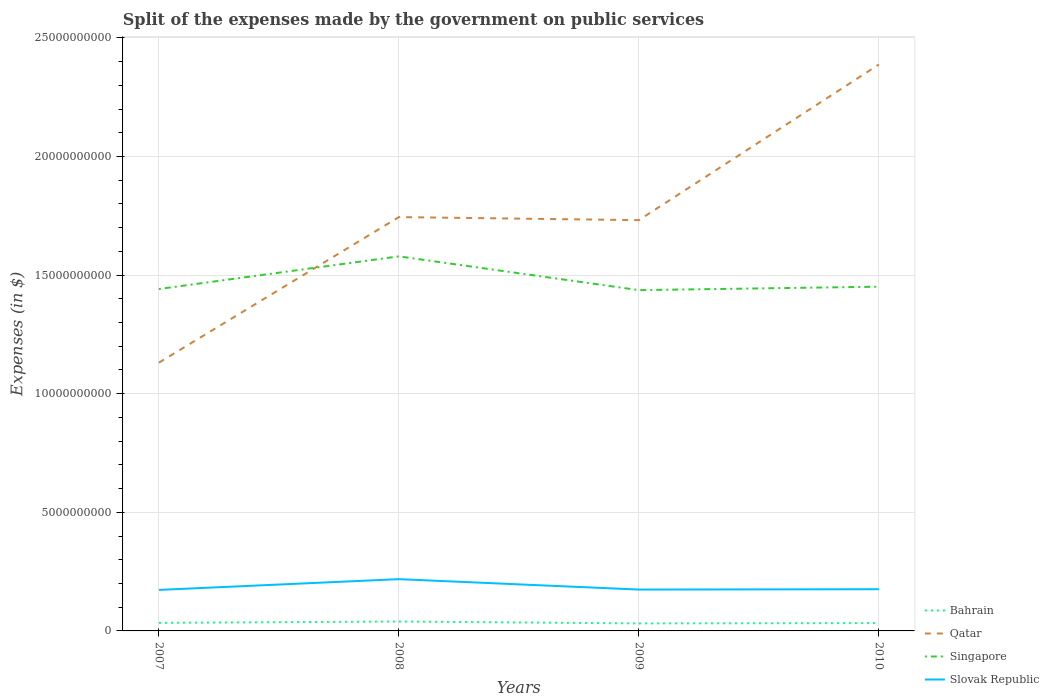How many different coloured lines are there?
Give a very brief answer. 4. Does the line corresponding to Qatar intersect with the line corresponding to Bahrain?
Offer a terse response. No. Across all years, what is the maximum expenses made by the government on public services in Qatar?
Offer a very short reply. 1.13e+1. In which year was the expenses made by the government on public services in Qatar maximum?
Make the answer very short. 2007. What is the total expenses made by the government on public services in Qatar in the graph?
Give a very brief answer. -6.14e+09. What is the difference between the highest and the second highest expenses made by the government on public services in Qatar?
Make the answer very short. 1.26e+1. What is the difference between the highest and the lowest expenses made by the government on public services in Qatar?
Your answer should be very brief. 1. How many lines are there?
Keep it short and to the point. 4. How many years are there in the graph?
Provide a succinct answer. 4. What is the difference between two consecutive major ticks on the Y-axis?
Your answer should be compact. 5.00e+09. Are the values on the major ticks of Y-axis written in scientific E-notation?
Offer a very short reply. No. Does the graph contain any zero values?
Offer a terse response. No. Does the graph contain grids?
Offer a terse response. Yes. How are the legend labels stacked?
Keep it short and to the point. Vertical. What is the title of the graph?
Ensure brevity in your answer.  Split of the expenses made by the government on public services. What is the label or title of the Y-axis?
Your response must be concise. Expenses (in $). What is the Expenses (in $) in Bahrain in 2007?
Ensure brevity in your answer.  3.39e+08. What is the Expenses (in $) in Qatar in 2007?
Offer a very short reply. 1.13e+1. What is the Expenses (in $) in Singapore in 2007?
Provide a short and direct response. 1.44e+1. What is the Expenses (in $) in Slovak Republic in 2007?
Provide a short and direct response. 1.73e+09. What is the Expenses (in $) of Bahrain in 2008?
Your response must be concise. 3.96e+08. What is the Expenses (in $) in Qatar in 2008?
Your response must be concise. 1.74e+1. What is the Expenses (in $) of Singapore in 2008?
Give a very brief answer. 1.58e+1. What is the Expenses (in $) of Slovak Republic in 2008?
Keep it short and to the point. 2.18e+09. What is the Expenses (in $) in Bahrain in 2009?
Your response must be concise. 3.18e+08. What is the Expenses (in $) of Qatar in 2009?
Provide a short and direct response. 1.73e+1. What is the Expenses (in $) of Singapore in 2009?
Offer a terse response. 1.44e+1. What is the Expenses (in $) of Slovak Republic in 2009?
Ensure brevity in your answer.  1.74e+09. What is the Expenses (in $) in Bahrain in 2010?
Your answer should be compact. 3.30e+08. What is the Expenses (in $) of Qatar in 2010?
Keep it short and to the point. 2.39e+1. What is the Expenses (in $) of Singapore in 2010?
Give a very brief answer. 1.45e+1. What is the Expenses (in $) of Slovak Republic in 2010?
Offer a terse response. 1.76e+09. Across all years, what is the maximum Expenses (in $) of Bahrain?
Make the answer very short. 3.96e+08. Across all years, what is the maximum Expenses (in $) of Qatar?
Make the answer very short. 2.39e+1. Across all years, what is the maximum Expenses (in $) of Singapore?
Provide a succinct answer. 1.58e+1. Across all years, what is the maximum Expenses (in $) in Slovak Republic?
Ensure brevity in your answer.  2.18e+09. Across all years, what is the minimum Expenses (in $) in Bahrain?
Your answer should be compact. 3.18e+08. Across all years, what is the minimum Expenses (in $) in Qatar?
Keep it short and to the point. 1.13e+1. Across all years, what is the minimum Expenses (in $) of Singapore?
Your answer should be very brief. 1.44e+1. Across all years, what is the minimum Expenses (in $) in Slovak Republic?
Give a very brief answer. 1.73e+09. What is the total Expenses (in $) in Bahrain in the graph?
Your response must be concise. 1.38e+09. What is the total Expenses (in $) of Qatar in the graph?
Offer a very short reply. 7.00e+1. What is the total Expenses (in $) in Singapore in the graph?
Give a very brief answer. 5.91e+1. What is the total Expenses (in $) of Slovak Republic in the graph?
Provide a short and direct response. 7.41e+09. What is the difference between the Expenses (in $) of Bahrain in 2007 and that in 2008?
Give a very brief answer. -5.70e+07. What is the difference between the Expenses (in $) in Qatar in 2007 and that in 2008?
Offer a terse response. -6.14e+09. What is the difference between the Expenses (in $) in Singapore in 2007 and that in 2008?
Your answer should be very brief. -1.38e+09. What is the difference between the Expenses (in $) of Slovak Republic in 2007 and that in 2008?
Make the answer very short. -4.53e+08. What is the difference between the Expenses (in $) in Bahrain in 2007 and that in 2009?
Provide a short and direct response. 2.19e+07. What is the difference between the Expenses (in $) of Qatar in 2007 and that in 2009?
Offer a terse response. -6.01e+09. What is the difference between the Expenses (in $) of Singapore in 2007 and that in 2009?
Ensure brevity in your answer.  4.70e+07. What is the difference between the Expenses (in $) in Slovak Republic in 2007 and that in 2009?
Offer a terse response. -1.42e+07. What is the difference between the Expenses (in $) in Bahrain in 2007 and that in 2010?
Give a very brief answer. 9.20e+06. What is the difference between the Expenses (in $) in Qatar in 2007 and that in 2010?
Give a very brief answer. -1.26e+1. What is the difference between the Expenses (in $) in Singapore in 2007 and that in 2010?
Offer a terse response. -9.78e+07. What is the difference between the Expenses (in $) in Slovak Republic in 2007 and that in 2010?
Your answer should be very brief. -2.88e+07. What is the difference between the Expenses (in $) of Bahrain in 2008 and that in 2009?
Offer a very short reply. 7.90e+07. What is the difference between the Expenses (in $) of Qatar in 2008 and that in 2009?
Make the answer very short. 1.29e+08. What is the difference between the Expenses (in $) of Singapore in 2008 and that in 2009?
Give a very brief answer. 1.42e+09. What is the difference between the Expenses (in $) of Slovak Republic in 2008 and that in 2009?
Provide a short and direct response. 4.39e+08. What is the difference between the Expenses (in $) of Bahrain in 2008 and that in 2010?
Your answer should be very brief. 6.62e+07. What is the difference between the Expenses (in $) in Qatar in 2008 and that in 2010?
Provide a short and direct response. -6.43e+09. What is the difference between the Expenses (in $) of Singapore in 2008 and that in 2010?
Ensure brevity in your answer.  1.28e+09. What is the difference between the Expenses (in $) in Slovak Republic in 2008 and that in 2010?
Provide a short and direct response. 4.24e+08. What is the difference between the Expenses (in $) of Bahrain in 2009 and that in 2010?
Offer a very short reply. -1.27e+07. What is the difference between the Expenses (in $) of Qatar in 2009 and that in 2010?
Your answer should be compact. -6.56e+09. What is the difference between the Expenses (in $) in Singapore in 2009 and that in 2010?
Provide a short and direct response. -1.45e+08. What is the difference between the Expenses (in $) in Slovak Republic in 2009 and that in 2010?
Your response must be concise. -1.45e+07. What is the difference between the Expenses (in $) of Bahrain in 2007 and the Expenses (in $) of Qatar in 2008?
Make the answer very short. -1.71e+1. What is the difference between the Expenses (in $) of Bahrain in 2007 and the Expenses (in $) of Singapore in 2008?
Give a very brief answer. -1.55e+1. What is the difference between the Expenses (in $) in Bahrain in 2007 and the Expenses (in $) in Slovak Republic in 2008?
Offer a terse response. -1.84e+09. What is the difference between the Expenses (in $) of Qatar in 2007 and the Expenses (in $) of Singapore in 2008?
Make the answer very short. -4.48e+09. What is the difference between the Expenses (in $) in Qatar in 2007 and the Expenses (in $) in Slovak Republic in 2008?
Offer a terse response. 9.13e+09. What is the difference between the Expenses (in $) in Singapore in 2007 and the Expenses (in $) in Slovak Republic in 2008?
Provide a short and direct response. 1.22e+1. What is the difference between the Expenses (in $) of Bahrain in 2007 and the Expenses (in $) of Qatar in 2009?
Provide a succinct answer. -1.70e+1. What is the difference between the Expenses (in $) in Bahrain in 2007 and the Expenses (in $) in Singapore in 2009?
Your response must be concise. -1.40e+1. What is the difference between the Expenses (in $) in Bahrain in 2007 and the Expenses (in $) in Slovak Republic in 2009?
Provide a short and direct response. -1.40e+09. What is the difference between the Expenses (in $) in Qatar in 2007 and the Expenses (in $) in Singapore in 2009?
Your answer should be compact. -3.06e+09. What is the difference between the Expenses (in $) of Qatar in 2007 and the Expenses (in $) of Slovak Republic in 2009?
Keep it short and to the point. 9.57e+09. What is the difference between the Expenses (in $) of Singapore in 2007 and the Expenses (in $) of Slovak Republic in 2009?
Offer a terse response. 1.27e+1. What is the difference between the Expenses (in $) of Bahrain in 2007 and the Expenses (in $) of Qatar in 2010?
Keep it short and to the point. -2.35e+1. What is the difference between the Expenses (in $) in Bahrain in 2007 and the Expenses (in $) in Singapore in 2010?
Ensure brevity in your answer.  -1.42e+1. What is the difference between the Expenses (in $) of Bahrain in 2007 and the Expenses (in $) of Slovak Republic in 2010?
Provide a succinct answer. -1.42e+09. What is the difference between the Expenses (in $) in Qatar in 2007 and the Expenses (in $) in Singapore in 2010?
Provide a succinct answer. -3.20e+09. What is the difference between the Expenses (in $) in Qatar in 2007 and the Expenses (in $) in Slovak Republic in 2010?
Ensure brevity in your answer.  9.55e+09. What is the difference between the Expenses (in $) in Singapore in 2007 and the Expenses (in $) in Slovak Republic in 2010?
Ensure brevity in your answer.  1.27e+1. What is the difference between the Expenses (in $) of Bahrain in 2008 and the Expenses (in $) of Qatar in 2009?
Make the answer very short. -1.69e+1. What is the difference between the Expenses (in $) in Bahrain in 2008 and the Expenses (in $) in Singapore in 2009?
Ensure brevity in your answer.  -1.40e+1. What is the difference between the Expenses (in $) of Bahrain in 2008 and the Expenses (in $) of Slovak Republic in 2009?
Provide a succinct answer. -1.35e+09. What is the difference between the Expenses (in $) in Qatar in 2008 and the Expenses (in $) in Singapore in 2009?
Your answer should be compact. 3.08e+09. What is the difference between the Expenses (in $) of Qatar in 2008 and the Expenses (in $) of Slovak Republic in 2009?
Provide a short and direct response. 1.57e+1. What is the difference between the Expenses (in $) in Singapore in 2008 and the Expenses (in $) in Slovak Republic in 2009?
Your response must be concise. 1.40e+1. What is the difference between the Expenses (in $) in Bahrain in 2008 and the Expenses (in $) in Qatar in 2010?
Provide a short and direct response. -2.35e+1. What is the difference between the Expenses (in $) in Bahrain in 2008 and the Expenses (in $) in Singapore in 2010?
Provide a short and direct response. -1.41e+1. What is the difference between the Expenses (in $) in Bahrain in 2008 and the Expenses (in $) in Slovak Republic in 2010?
Offer a very short reply. -1.36e+09. What is the difference between the Expenses (in $) in Qatar in 2008 and the Expenses (in $) in Singapore in 2010?
Provide a short and direct response. 2.93e+09. What is the difference between the Expenses (in $) of Qatar in 2008 and the Expenses (in $) of Slovak Republic in 2010?
Make the answer very short. 1.57e+1. What is the difference between the Expenses (in $) in Singapore in 2008 and the Expenses (in $) in Slovak Republic in 2010?
Offer a very short reply. 1.40e+1. What is the difference between the Expenses (in $) of Bahrain in 2009 and the Expenses (in $) of Qatar in 2010?
Give a very brief answer. -2.36e+1. What is the difference between the Expenses (in $) of Bahrain in 2009 and the Expenses (in $) of Singapore in 2010?
Your answer should be compact. -1.42e+1. What is the difference between the Expenses (in $) of Bahrain in 2009 and the Expenses (in $) of Slovak Republic in 2010?
Provide a short and direct response. -1.44e+09. What is the difference between the Expenses (in $) of Qatar in 2009 and the Expenses (in $) of Singapore in 2010?
Your answer should be very brief. 2.81e+09. What is the difference between the Expenses (in $) of Qatar in 2009 and the Expenses (in $) of Slovak Republic in 2010?
Make the answer very short. 1.56e+1. What is the difference between the Expenses (in $) in Singapore in 2009 and the Expenses (in $) in Slovak Republic in 2010?
Offer a terse response. 1.26e+1. What is the average Expenses (in $) in Bahrain per year?
Ensure brevity in your answer.  3.46e+08. What is the average Expenses (in $) of Qatar per year?
Keep it short and to the point. 1.75e+1. What is the average Expenses (in $) in Singapore per year?
Give a very brief answer. 1.48e+1. What is the average Expenses (in $) of Slovak Republic per year?
Make the answer very short. 1.85e+09. In the year 2007, what is the difference between the Expenses (in $) in Bahrain and Expenses (in $) in Qatar?
Provide a short and direct response. -1.10e+1. In the year 2007, what is the difference between the Expenses (in $) in Bahrain and Expenses (in $) in Singapore?
Provide a short and direct response. -1.41e+1. In the year 2007, what is the difference between the Expenses (in $) in Bahrain and Expenses (in $) in Slovak Republic?
Provide a succinct answer. -1.39e+09. In the year 2007, what is the difference between the Expenses (in $) of Qatar and Expenses (in $) of Singapore?
Your response must be concise. -3.10e+09. In the year 2007, what is the difference between the Expenses (in $) in Qatar and Expenses (in $) in Slovak Republic?
Provide a short and direct response. 9.58e+09. In the year 2007, what is the difference between the Expenses (in $) of Singapore and Expenses (in $) of Slovak Republic?
Keep it short and to the point. 1.27e+1. In the year 2008, what is the difference between the Expenses (in $) of Bahrain and Expenses (in $) of Qatar?
Your response must be concise. -1.70e+1. In the year 2008, what is the difference between the Expenses (in $) of Bahrain and Expenses (in $) of Singapore?
Provide a short and direct response. -1.54e+1. In the year 2008, what is the difference between the Expenses (in $) of Bahrain and Expenses (in $) of Slovak Republic?
Offer a very short reply. -1.79e+09. In the year 2008, what is the difference between the Expenses (in $) of Qatar and Expenses (in $) of Singapore?
Ensure brevity in your answer.  1.66e+09. In the year 2008, what is the difference between the Expenses (in $) of Qatar and Expenses (in $) of Slovak Republic?
Your answer should be compact. 1.53e+1. In the year 2008, what is the difference between the Expenses (in $) of Singapore and Expenses (in $) of Slovak Republic?
Your answer should be compact. 1.36e+1. In the year 2009, what is the difference between the Expenses (in $) of Bahrain and Expenses (in $) of Qatar?
Offer a terse response. -1.70e+1. In the year 2009, what is the difference between the Expenses (in $) of Bahrain and Expenses (in $) of Singapore?
Your answer should be compact. -1.40e+1. In the year 2009, what is the difference between the Expenses (in $) of Bahrain and Expenses (in $) of Slovak Republic?
Provide a short and direct response. -1.43e+09. In the year 2009, what is the difference between the Expenses (in $) in Qatar and Expenses (in $) in Singapore?
Ensure brevity in your answer.  2.95e+09. In the year 2009, what is the difference between the Expenses (in $) of Qatar and Expenses (in $) of Slovak Republic?
Provide a succinct answer. 1.56e+1. In the year 2009, what is the difference between the Expenses (in $) of Singapore and Expenses (in $) of Slovak Republic?
Offer a terse response. 1.26e+1. In the year 2010, what is the difference between the Expenses (in $) in Bahrain and Expenses (in $) in Qatar?
Make the answer very short. -2.35e+1. In the year 2010, what is the difference between the Expenses (in $) in Bahrain and Expenses (in $) in Singapore?
Keep it short and to the point. -1.42e+1. In the year 2010, what is the difference between the Expenses (in $) in Bahrain and Expenses (in $) in Slovak Republic?
Your answer should be compact. -1.43e+09. In the year 2010, what is the difference between the Expenses (in $) in Qatar and Expenses (in $) in Singapore?
Make the answer very short. 9.37e+09. In the year 2010, what is the difference between the Expenses (in $) of Qatar and Expenses (in $) of Slovak Republic?
Offer a very short reply. 2.21e+1. In the year 2010, what is the difference between the Expenses (in $) of Singapore and Expenses (in $) of Slovak Republic?
Give a very brief answer. 1.28e+1. What is the ratio of the Expenses (in $) of Bahrain in 2007 to that in 2008?
Your answer should be very brief. 0.86. What is the ratio of the Expenses (in $) of Qatar in 2007 to that in 2008?
Keep it short and to the point. 0.65. What is the ratio of the Expenses (in $) in Singapore in 2007 to that in 2008?
Ensure brevity in your answer.  0.91. What is the ratio of the Expenses (in $) in Slovak Republic in 2007 to that in 2008?
Keep it short and to the point. 0.79. What is the ratio of the Expenses (in $) of Bahrain in 2007 to that in 2009?
Your answer should be very brief. 1.07. What is the ratio of the Expenses (in $) of Qatar in 2007 to that in 2009?
Provide a succinct answer. 0.65. What is the ratio of the Expenses (in $) of Slovak Republic in 2007 to that in 2009?
Your answer should be very brief. 0.99. What is the ratio of the Expenses (in $) of Bahrain in 2007 to that in 2010?
Provide a short and direct response. 1.03. What is the ratio of the Expenses (in $) in Qatar in 2007 to that in 2010?
Provide a short and direct response. 0.47. What is the ratio of the Expenses (in $) in Singapore in 2007 to that in 2010?
Provide a short and direct response. 0.99. What is the ratio of the Expenses (in $) of Slovak Republic in 2007 to that in 2010?
Make the answer very short. 0.98. What is the ratio of the Expenses (in $) of Bahrain in 2008 to that in 2009?
Offer a terse response. 1.25. What is the ratio of the Expenses (in $) in Qatar in 2008 to that in 2009?
Keep it short and to the point. 1.01. What is the ratio of the Expenses (in $) in Singapore in 2008 to that in 2009?
Your answer should be very brief. 1.1. What is the ratio of the Expenses (in $) in Slovak Republic in 2008 to that in 2009?
Your answer should be compact. 1.25. What is the ratio of the Expenses (in $) in Bahrain in 2008 to that in 2010?
Offer a very short reply. 1.2. What is the ratio of the Expenses (in $) of Qatar in 2008 to that in 2010?
Your answer should be very brief. 0.73. What is the ratio of the Expenses (in $) in Singapore in 2008 to that in 2010?
Offer a very short reply. 1.09. What is the ratio of the Expenses (in $) of Slovak Republic in 2008 to that in 2010?
Your answer should be compact. 1.24. What is the ratio of the Expenses (in $) of Bahrain in 2009 to that in 2010?
Your response must be concise. 0.96. What is the ratio of the Expenses (in $) of Qatar in 2009 to that in 2010?
Ensure brevity in your answer.  0.73. What is the difference between the highest and the second highest Expenses (in $) in Bahrain?
Your answer should be very brief. 5.70e+07. What is the difference between the highest and the second highest Expenses (in $) in Qatar?
Offer a very short reply. 6.43e+09. What is the difference between the highest and the second highest Expenses (in $) in Singapore?
Make the answer very short. 1.28e+09. What is the difference between the highest and the second highest Expenses (in $) of Slovak Republic?
Provide a succinct answer. 4.24e+08. What is the difference between the highest and the lowest Expenses (in $) of Bahrain?
Ensure brevity in your answer.  7.90e+07. What is the difference between the highest and the lowest Expenses (in $) of Qatar?
Make the answer very short. 1.26e+1. What is the difference between the highest and the lowest Expenses (in $) in Singapore?
Your answer should be very brief. 1.42e+09. What is the difference between the highest and the lowest Expenses (in $) in Slovak Republic?
Provide a short and direct response. 4.53e+08. 